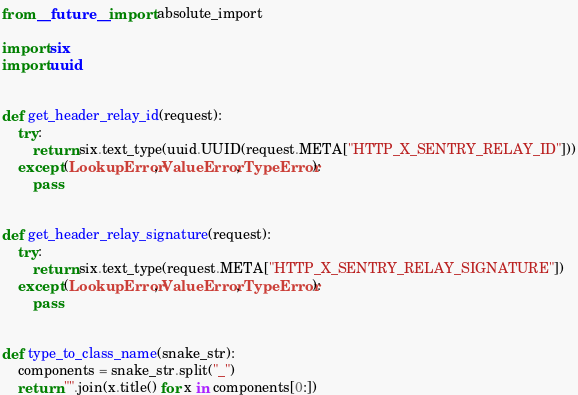Convert code to text. <code><loc_0><loc_0><loc_500><loc_500><_Python_>from __future__ import absolute_import

import six
import uuid


def get_header_relay_id(request):
    try:
        return six.text_type(uuid.UUID(request.META["HTTP_X_SENTRY_RELAY_ID"]))
    except (LookupError, ValueError, TypeError):
        pass


def get_header_relay_signature(request):
    try:
        return six.text_type(request.META["HTTP_X_SENTRY_RELAY_SIGNATURE"])
    except (LookupError, ValueError, TypeError):
        pass


def type_to_class_name(snake_str):
    components = snake_str.split("_")
    return "".join(x.title() for x in components[0:])
</code> 